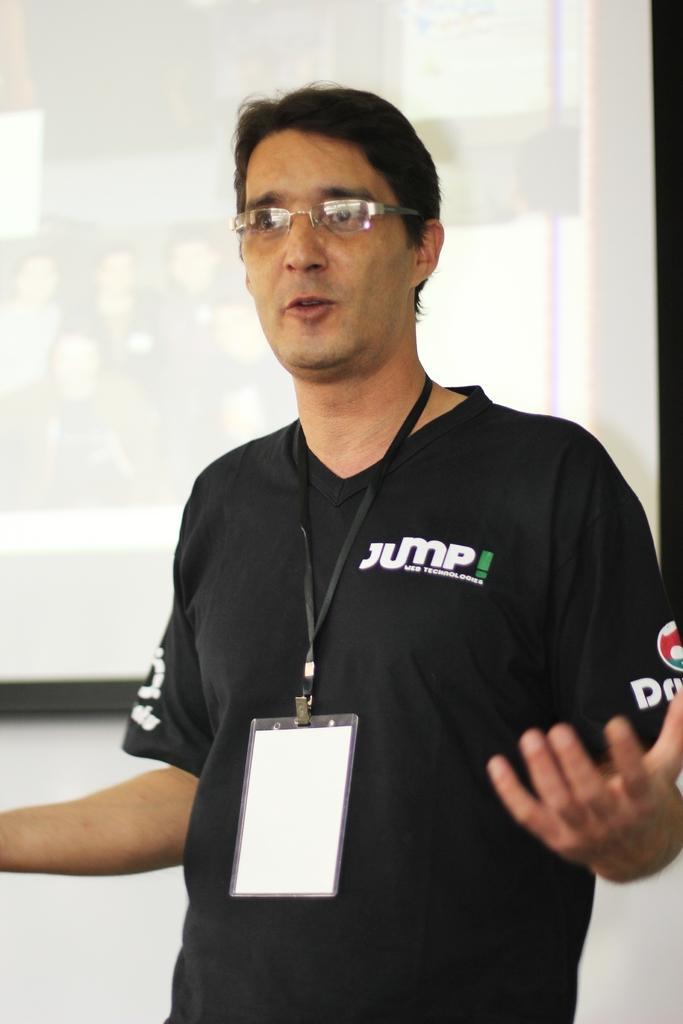Describe this image in one or two sentences. In this image I can see the person wearing the black color dress and an identification card. I can see the person wearing the specs. In the background I can see the screen and the wall. 